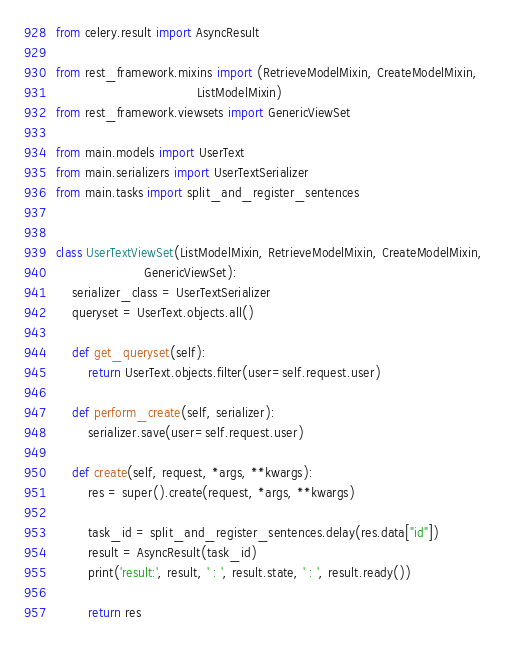<code> <loc_0><loc_0><loc_500><loc_500><_Python_>from celery.result import AsyncResult

from rest_framework.mixins import (RetrieveModelMixin, CreateModelMixin,
                                   ListModelMixin)
from rest_framework.viewsets import GenericViewSet

from main.models import UserText
from main.serializers import UserTextSerializer
from main.tasks import split_and_register_sentences


class UserTextViewSet(ListModelMixin, RetrieveModelMixin, CreateModelMixin,
                      GenericViewSet):
    serializer_class = UserTextSerializer
    queryset = UserText.objects.all()

    def get_queryset(self):
        return UserText.objects.filter(user=self.request.user)

    def perform_create(self, serializer):
        serializer.save(user=self.request.user)

    def create(self, request, *args, **kwargs):
        res = super().create(request, *args, **kwargs)

        task_id = split_and_register_sentences.delay(res.data["id"])
        result = AsyncResult(task_id)
        print('result:', result, ' : ', result.state, ' : ', result.ready())

        return res
</code> 